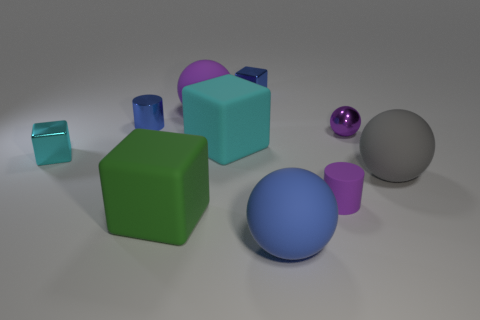What can you tell me about the lighting in this scene? The lighting suggests an indoor setup with a primary light source to the right, casting diffuse shadows to the left of the objects, providing a soft appearance to the scene. 